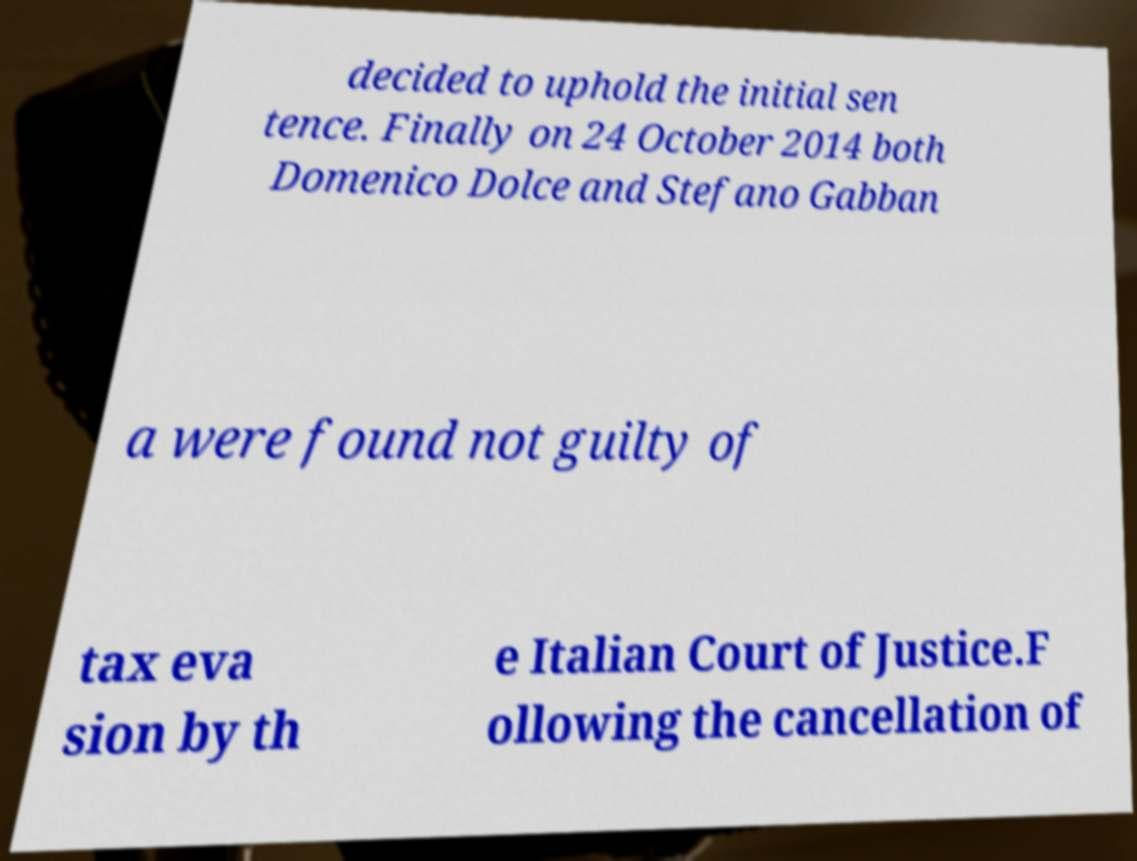There's text embedded in this image that I need extracted. Can you transcribe it verbatim? decided to uphold the initial sen tence. Finally on 24 October 2014 both Domenico Dolce and Stefano Gabban a were found not guilty of tax eva sion by th e Italian Court of Justice.F ollowing the cancellation of 